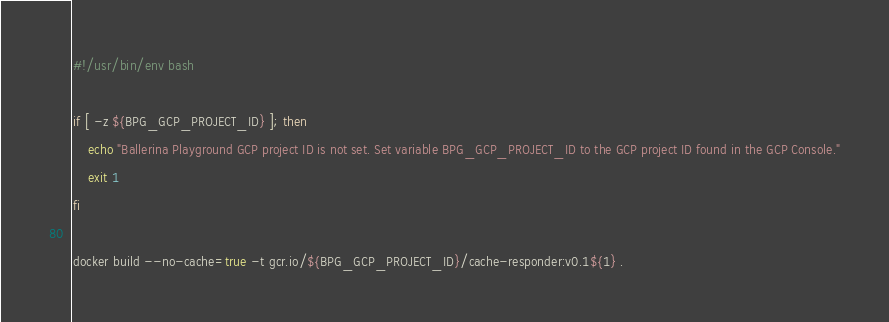Convert code to text. <code><loc_0><loc_0><loc_500><loc_500><_Bash_>#!/usr/bin/env bash

if [ -z ${BPG_GCP_PROJECT_ID} ]; then
    echo "Ballerina Playground GCP project ID is not set. Set variable BPG_GCP_PROJECT_ID to the GCP project ID found in the GCP Console."
    exit 1
fi

docker build --no-cache=true -t gcr.io/${BPG_GCP_PROJECT_ID}/cache-responder:v0.1${1} .</code> 